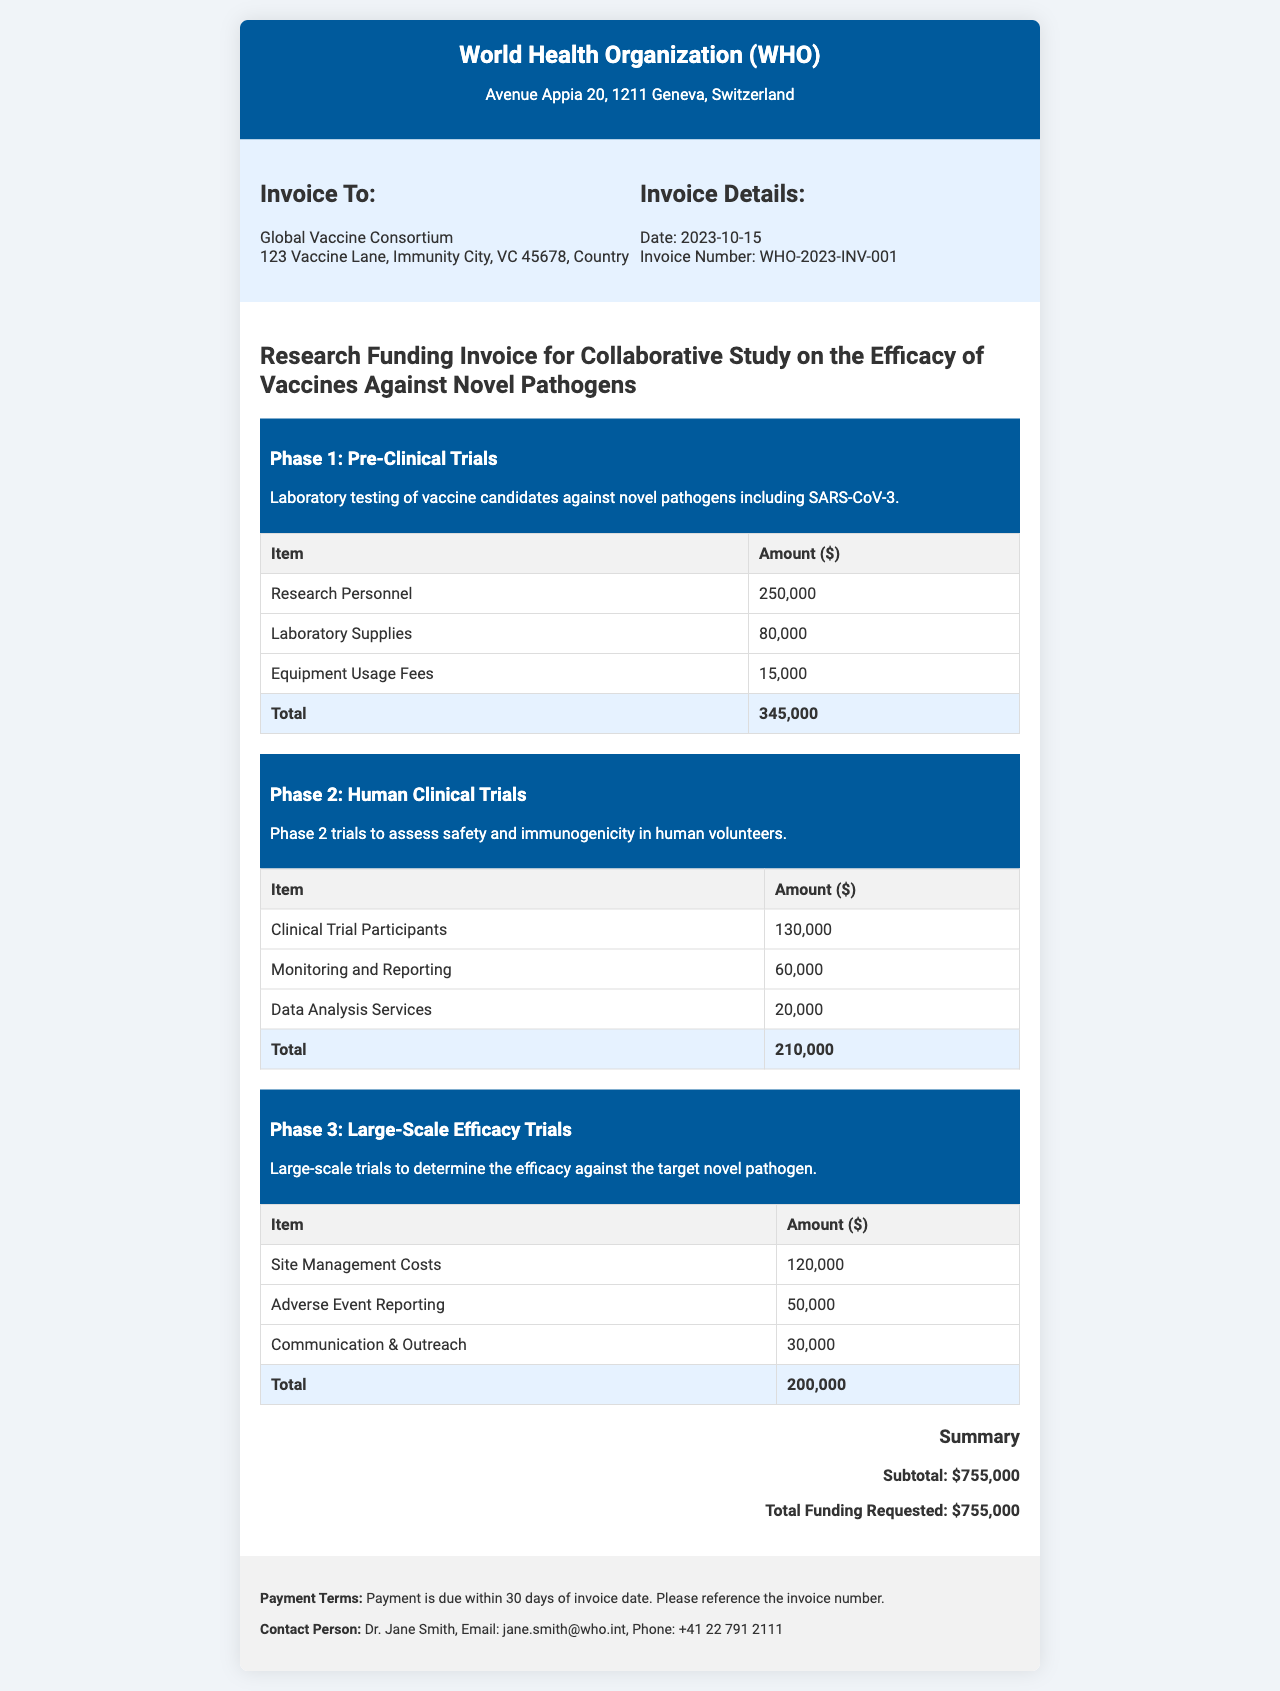What is the total funding requested? The total funding requested is stated in the summary section of the document, which lists the total as $755,000.
Answer: $755,000 What is the invoice number? The invoice number is located in the invoice details section, specifically indicated as WHO-2023-INV-001.
Answer: WHO-2023-INV-001 Who is the contact person for this invoice? The contact person is mentioned in the footer section of the document, identified as Dr. Jane Smith.
Answer: Dr. Jane Smith How much is allocated for research personnel in Phase 1? The amount allocated for research personnel is listed in the Phase 1 section of the invoice as $250,000.
Answer: $250,000 What is the subtotal before any additional costs? The subtotal is calculated from the totals of each phase in the summary section, which adds up to $755,000.
Answer: $755,000 In which phase is data analysis services listed? Data analysis services are mentioned under Phase 2, which focuses on human clinical trials.
Answer: Phase 2 How much is allocated for monitoring and reporting in Phase 2? The amount allocated for monitoring and reporting is specifically stated as $60,000 in Phase 2.
Answer: $60,000 What are the payment terms mentioned in the document? The payment terms are outlined in the footer, stating that payment is due within 30 days of the invoice date.
Answer: 30 days What is the total amount for Phase 3? The total amount for Phase 3 is stated at the end of the Phase 3 table, which is $200,000.
Answer: $200,000 